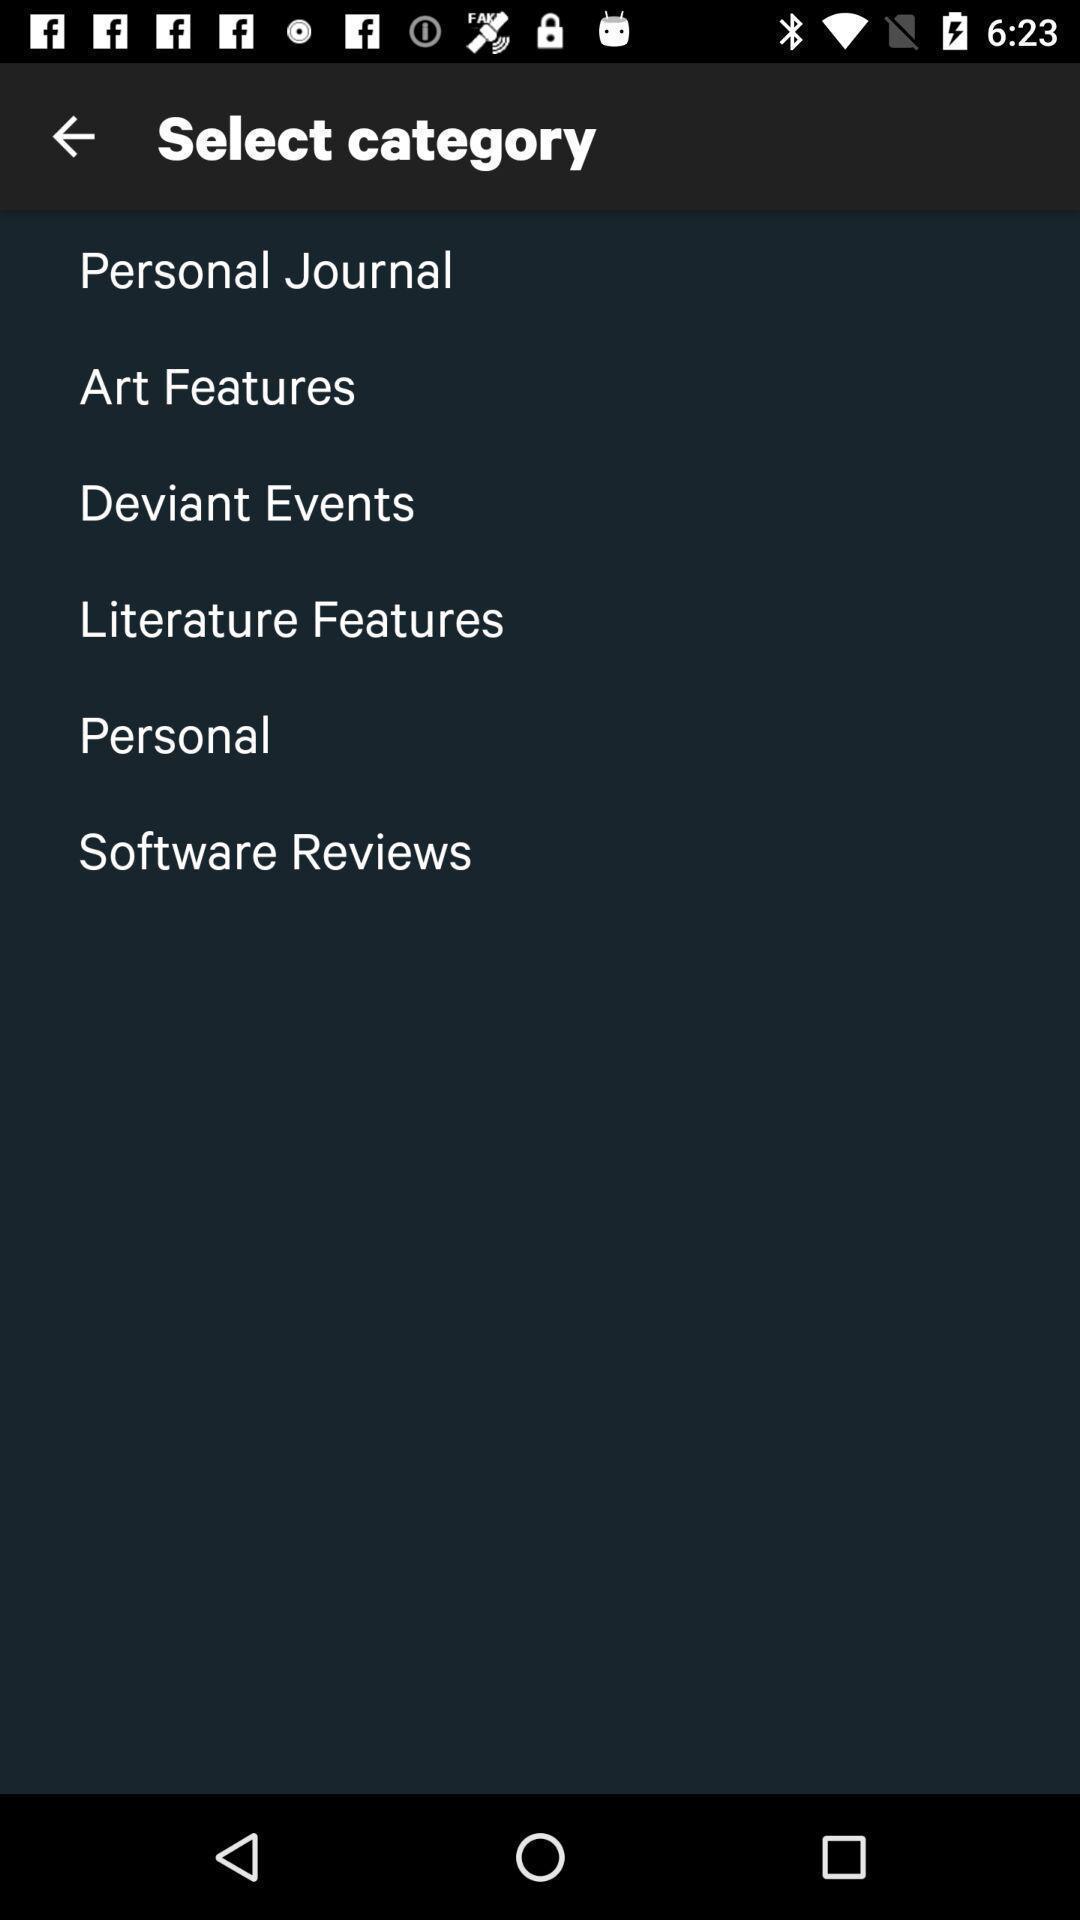Tell me what you see in this picture. Page displaying to select a category. 